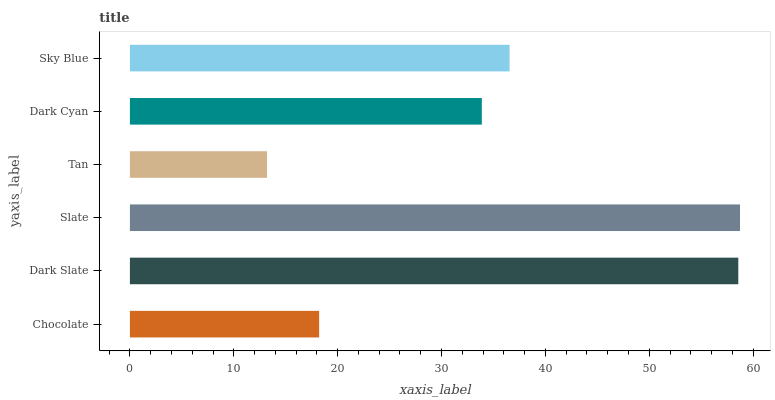Is Tan the minimum?
Answer yes or no. Yes. Is Slate the maximum?
Answer yes or no. Yes. Is Dark Slate the minimum?
Answer yes or no. No. Is Dark Slate the maximum?
Answer yes or no. No. Is Dark Slate greater than Chocolate?
Answer yes or no. Yes. Is Chocolate less than Dark Slate?
Answer yes or no. Yes. Is Chocolate greater than Dark Slate?
Answer yes or no. No. Is Dark Slate less than Chocolate?
Answer yes or no. No. Is Sky Blue the high median?
Answer yes or no. Yes. Is Dark Cyan the low median?
Answer yes or no. Yes. Is Chocolate the high median?
Answer yes or no. No. Is Sky Blue the low median?
Answer yes or no. No. 